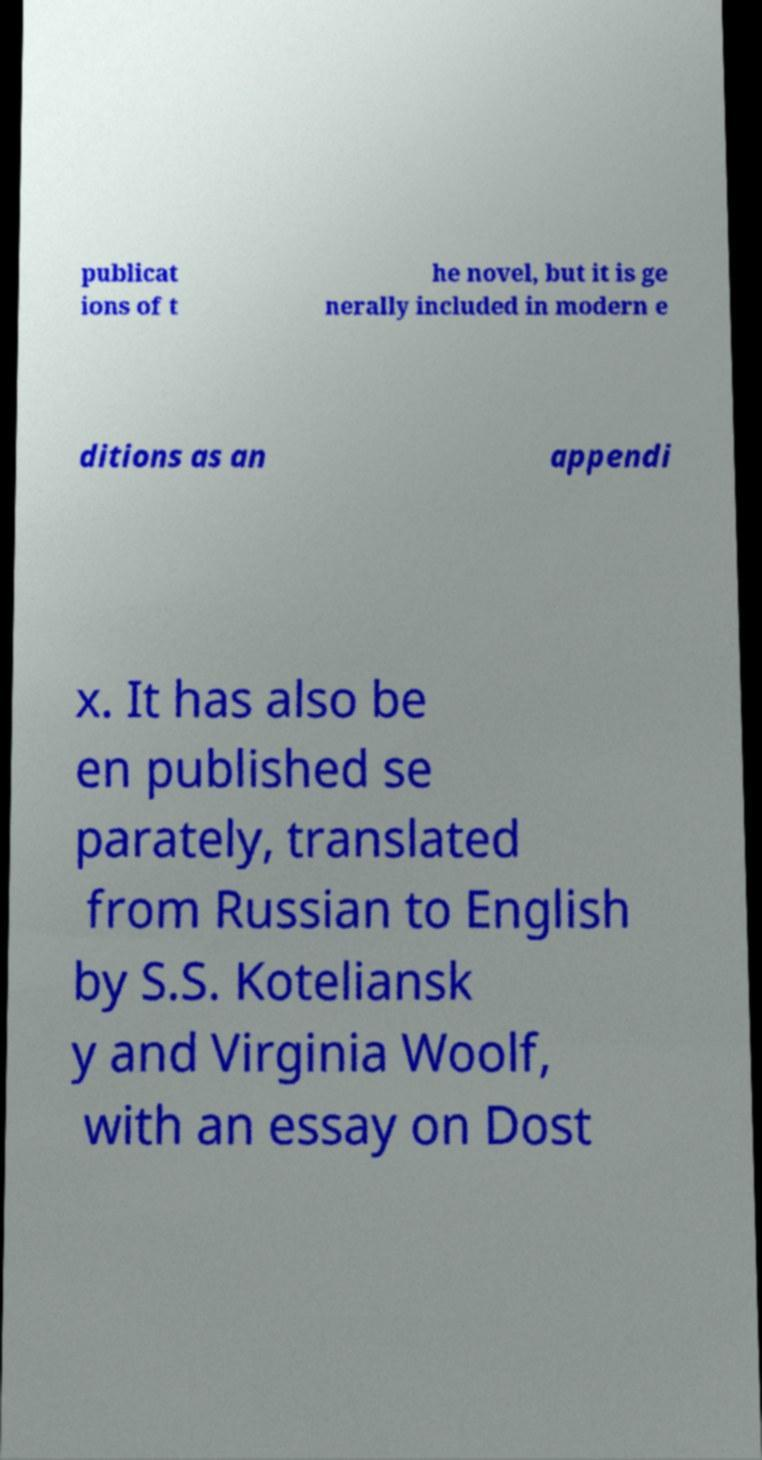Please identify and transcribe the text found in this image. publicat ions of t he novel, but it is ge nerally included in modern e ditions as an appendi x. It has also be en published se parately, translated from Russian to English by S.S. Koteliansk y and Virginia Woolf, with an essay on Dost 